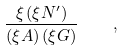Convert formula to latex. <formula><loc_0><loc_0><loc_500><loc_500>\frac { \xi \, ( \xi N ^ { \prime } ) } { ( \xi A ) \, ( \xi G ) } \quad ,</formula> 